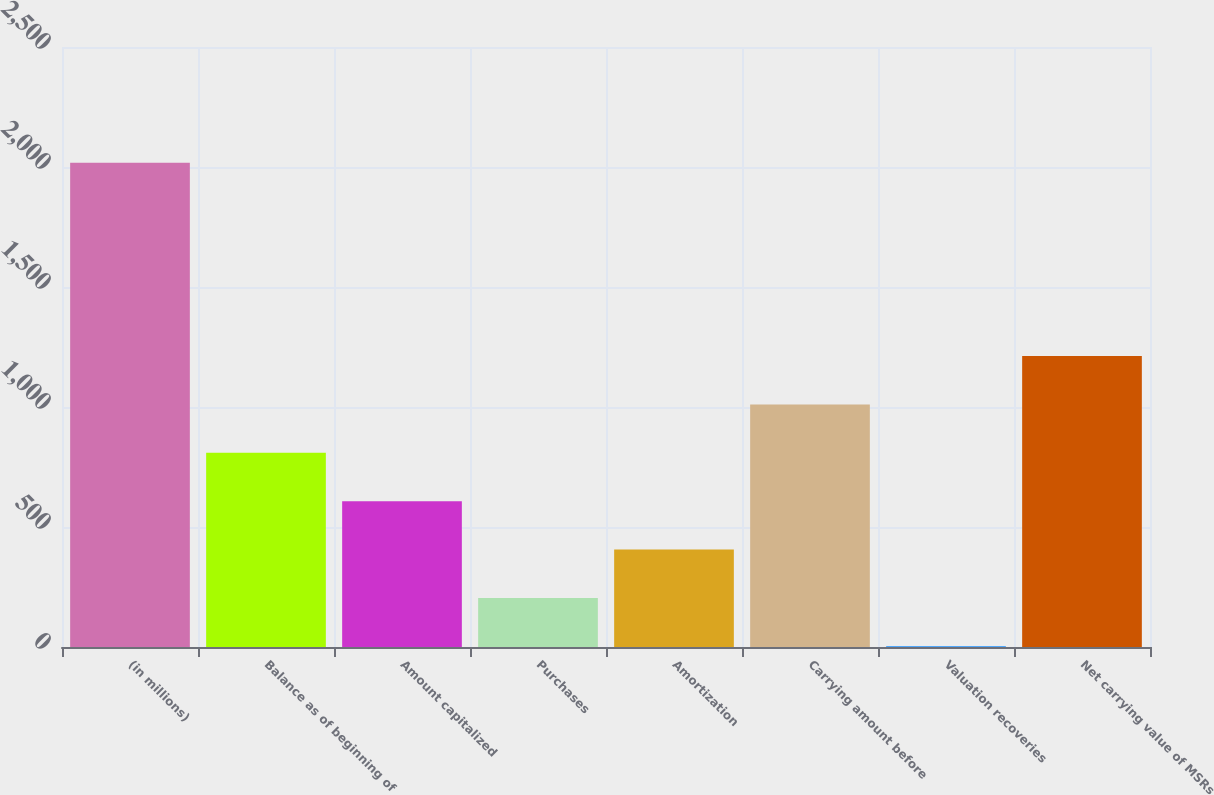<chart> <loc_0><loc_0><loc_500><loc_500><bar_chart><fcel>(in millions)<fcel>Balance as of beginning of<fcel>Amount capitalized<fcel>Purchases<fcel>Amortization<fcel>Carrying amount before<fcel>Valuation recoveries<fcel>Net carrying value of MSRs<nl><fcel>2018<fcel>809<fcel>607.5<fcel>204.5<fcel>406<fcel>1010.5<fcel>3<fcel>1212<nl></chart> 